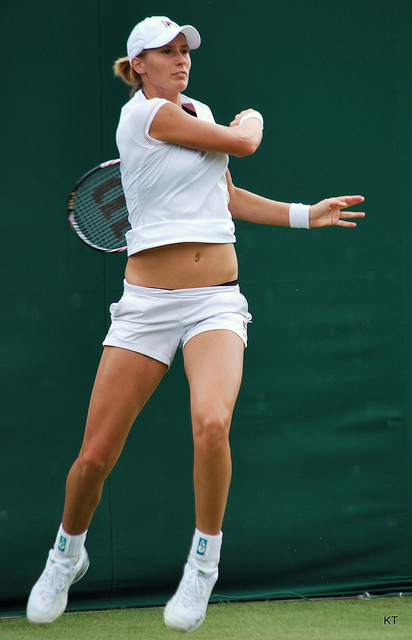Identify the text displayed in this image. KT 